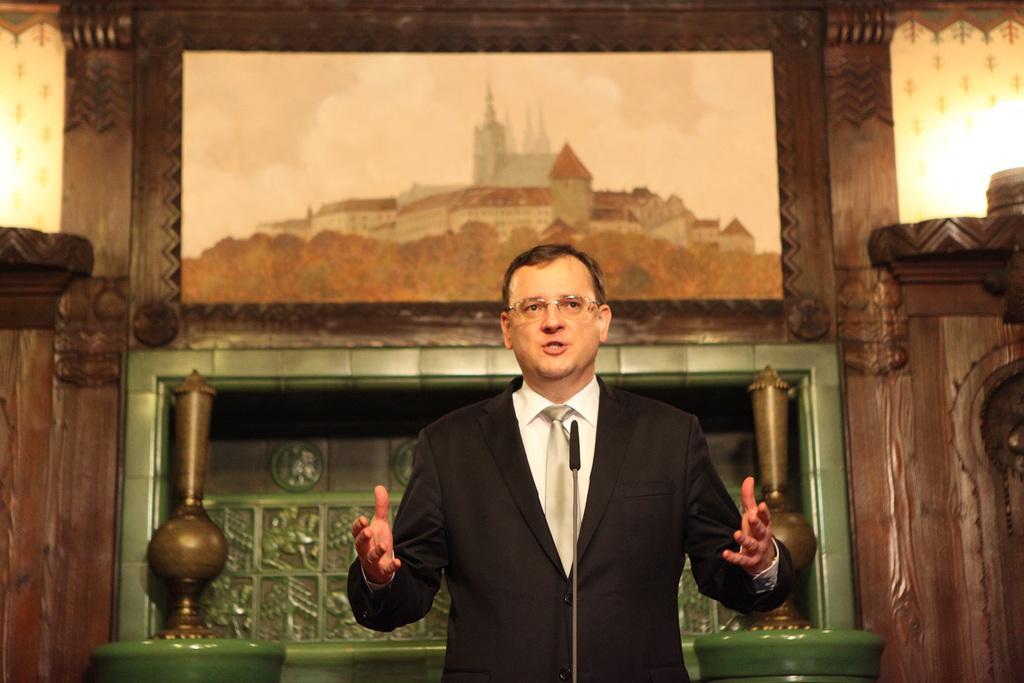Could you give a brief overview of what you see in this image? In this image I can see the person standing and wearing the white and black color dress. He is also wearing the specs. In-front of the person I can see the mic. In the back there is a frame attached to the wall. In the frame I can see the building and the sky. I can also see few decorative vases which are in brown color. 